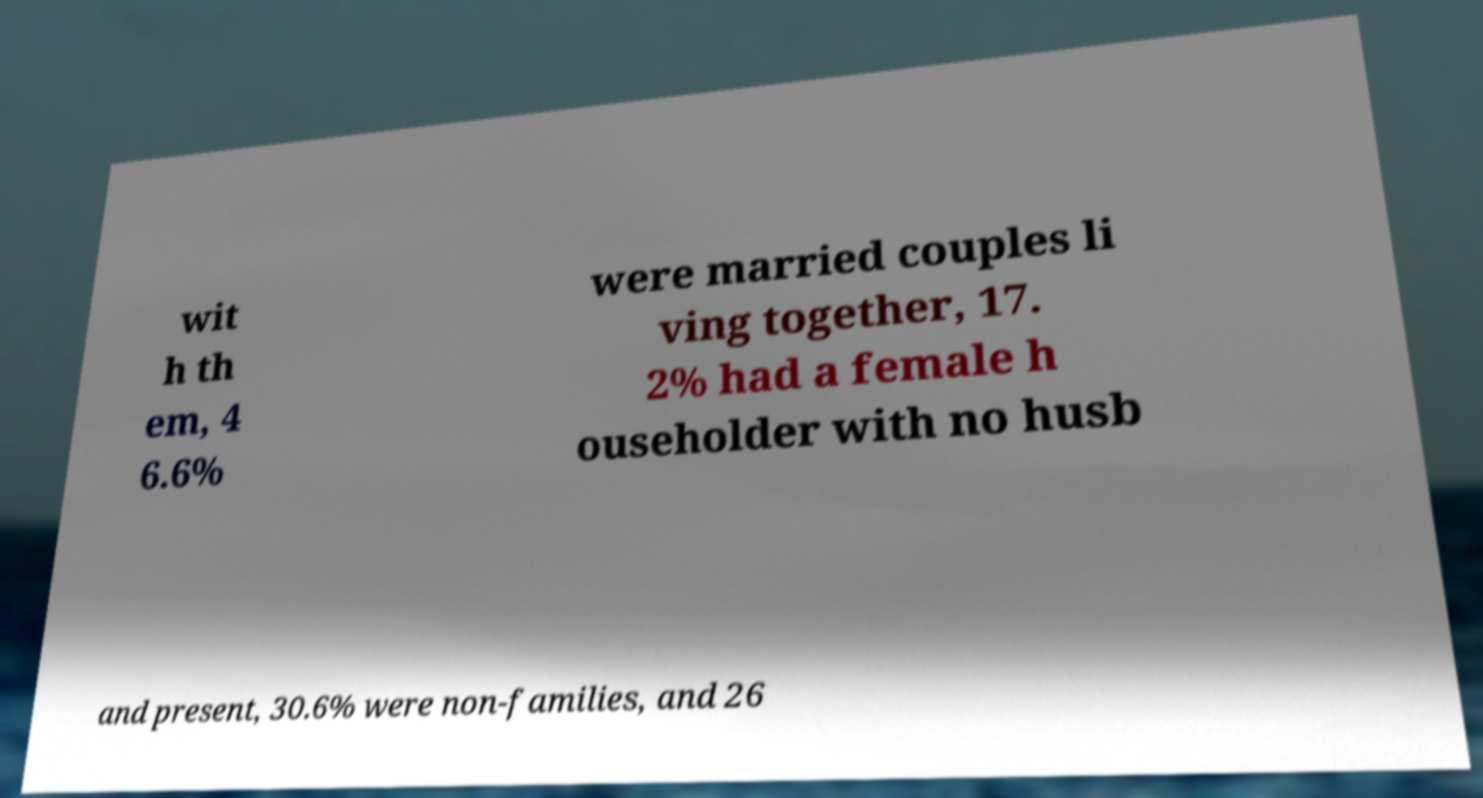Can you accurately transcribe the text from the provided image for me? wit h th em, 4 6.6% were married couples li ving together, 17. 2% had a female h ouseholder with no husb and present, 30.6% were non-families, and 26 